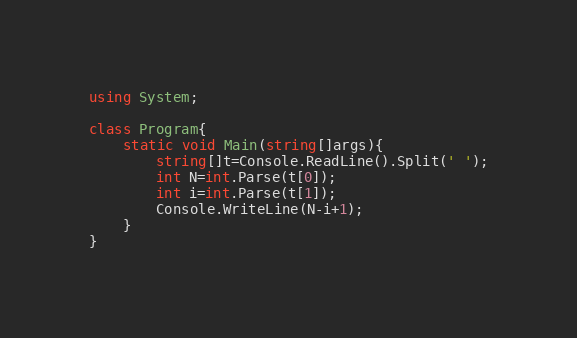<code> <loc_0><loc_0><loc_500><loc_500><_C#_>using System;

class Program{
    static void Main(string[]args){
        string[]t=Console.ReadLine().Split(' ');
        int N=int.Parse(t[0]);
        int i=int.Parse(t[1]);
        Console.WriteLine(N-i+1);
    }
}</code> 